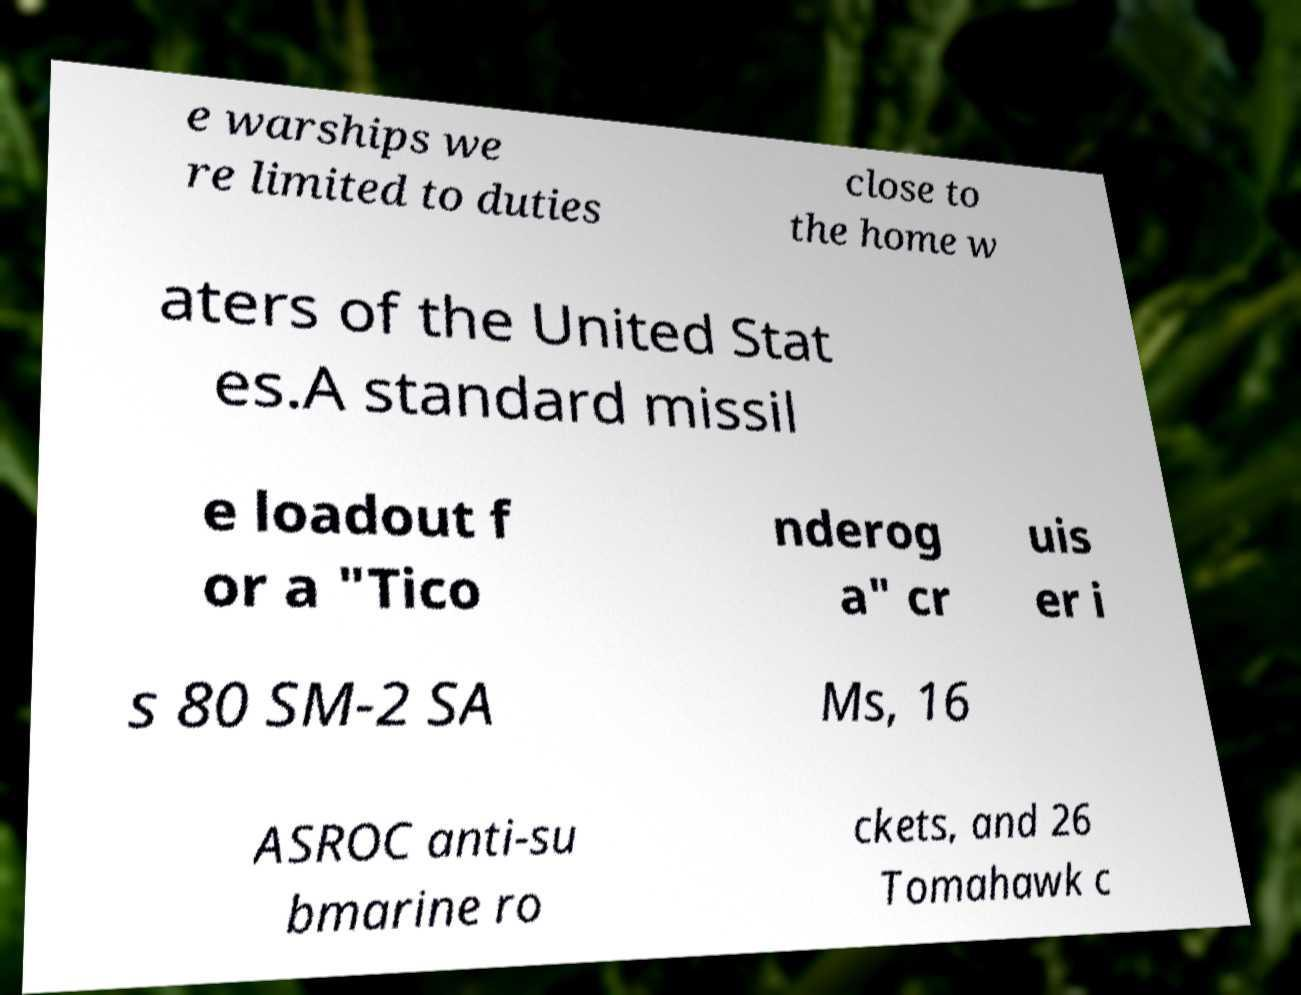For documentation purposes, I need the text within this image transcribed. Could you provide that? e warships we re limited to duties close to the home w aters of the United Stat es.A standard missil e loadout f or a "Tico nderog a" cr uis er i s 80 SM-2 SA Ms, 16 ASROC anti-su bmarine ro ckets, and 26 Tomahawk c 